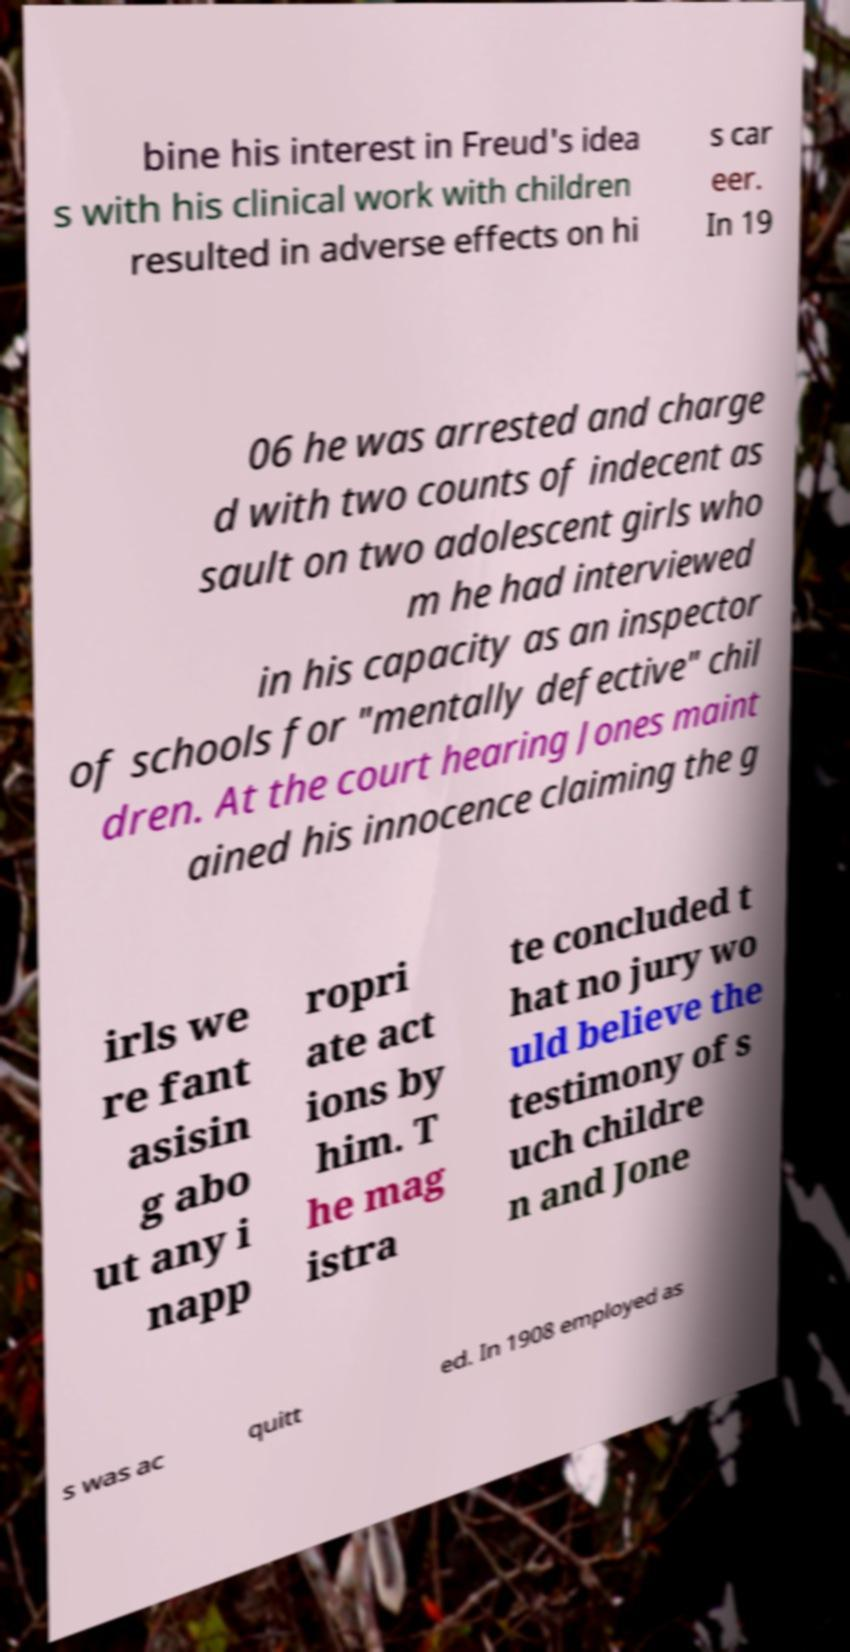What messages or text are displayed in this image? I need them in a readable, typed format. bine his interest in Freud's idea s with his clinical work with children resulted in adverse effects on hi s car eer. In 19 06 he was arrested and charge d with two counts of indecent as sault on two adolescent girls who m he had interviewed in his capacity as an inspector of schools for "mentally defective" chil dren. At the court hearing Jones maint ained his innocence claiming the g irls we re fant asisin g abo ut any i napp ropri ate act ions by him. T he mag istra te concluded t hat no jury wo uld believe the testimony of s uch childre n and Jone s was ac quitt ed. In 1908 employed as 